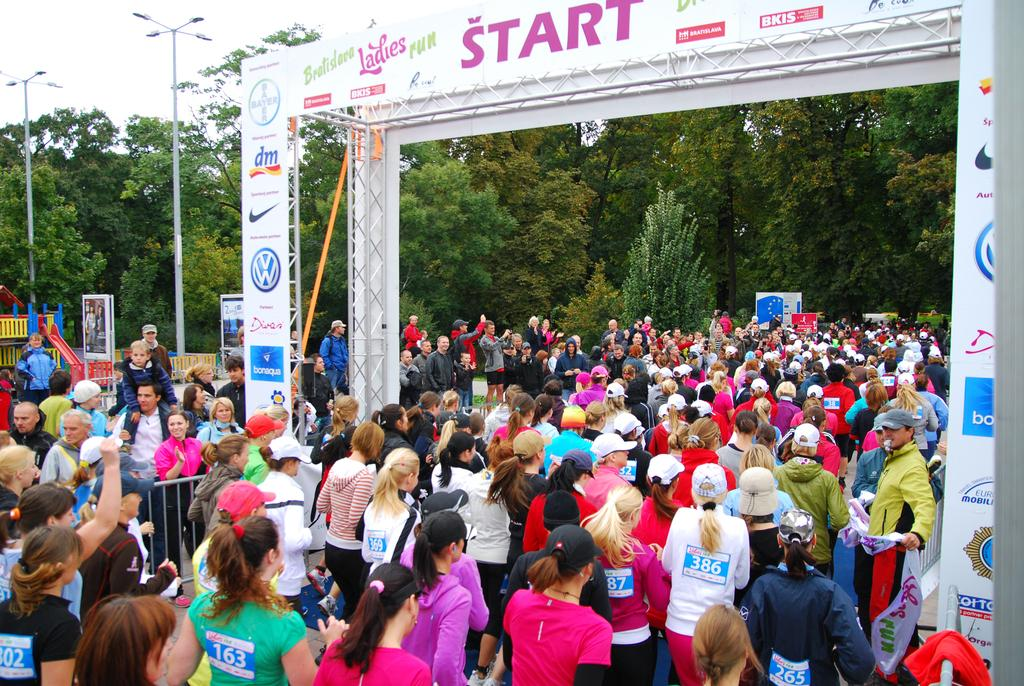What can be seen in the image? There is a group of women in the image. What are the women doing in the image? The women are walking through an entrance. What can be seen in the background of the image? There are trees visible in the long back side of the image. How many houses can be seen in the image? There are no houses visible in the image; it features a group of women walking through an entrance with trees in the background. Is there a baby present in the image? There is no baby present in the image; it features a group of women walking through an entrance with trees in the background. 